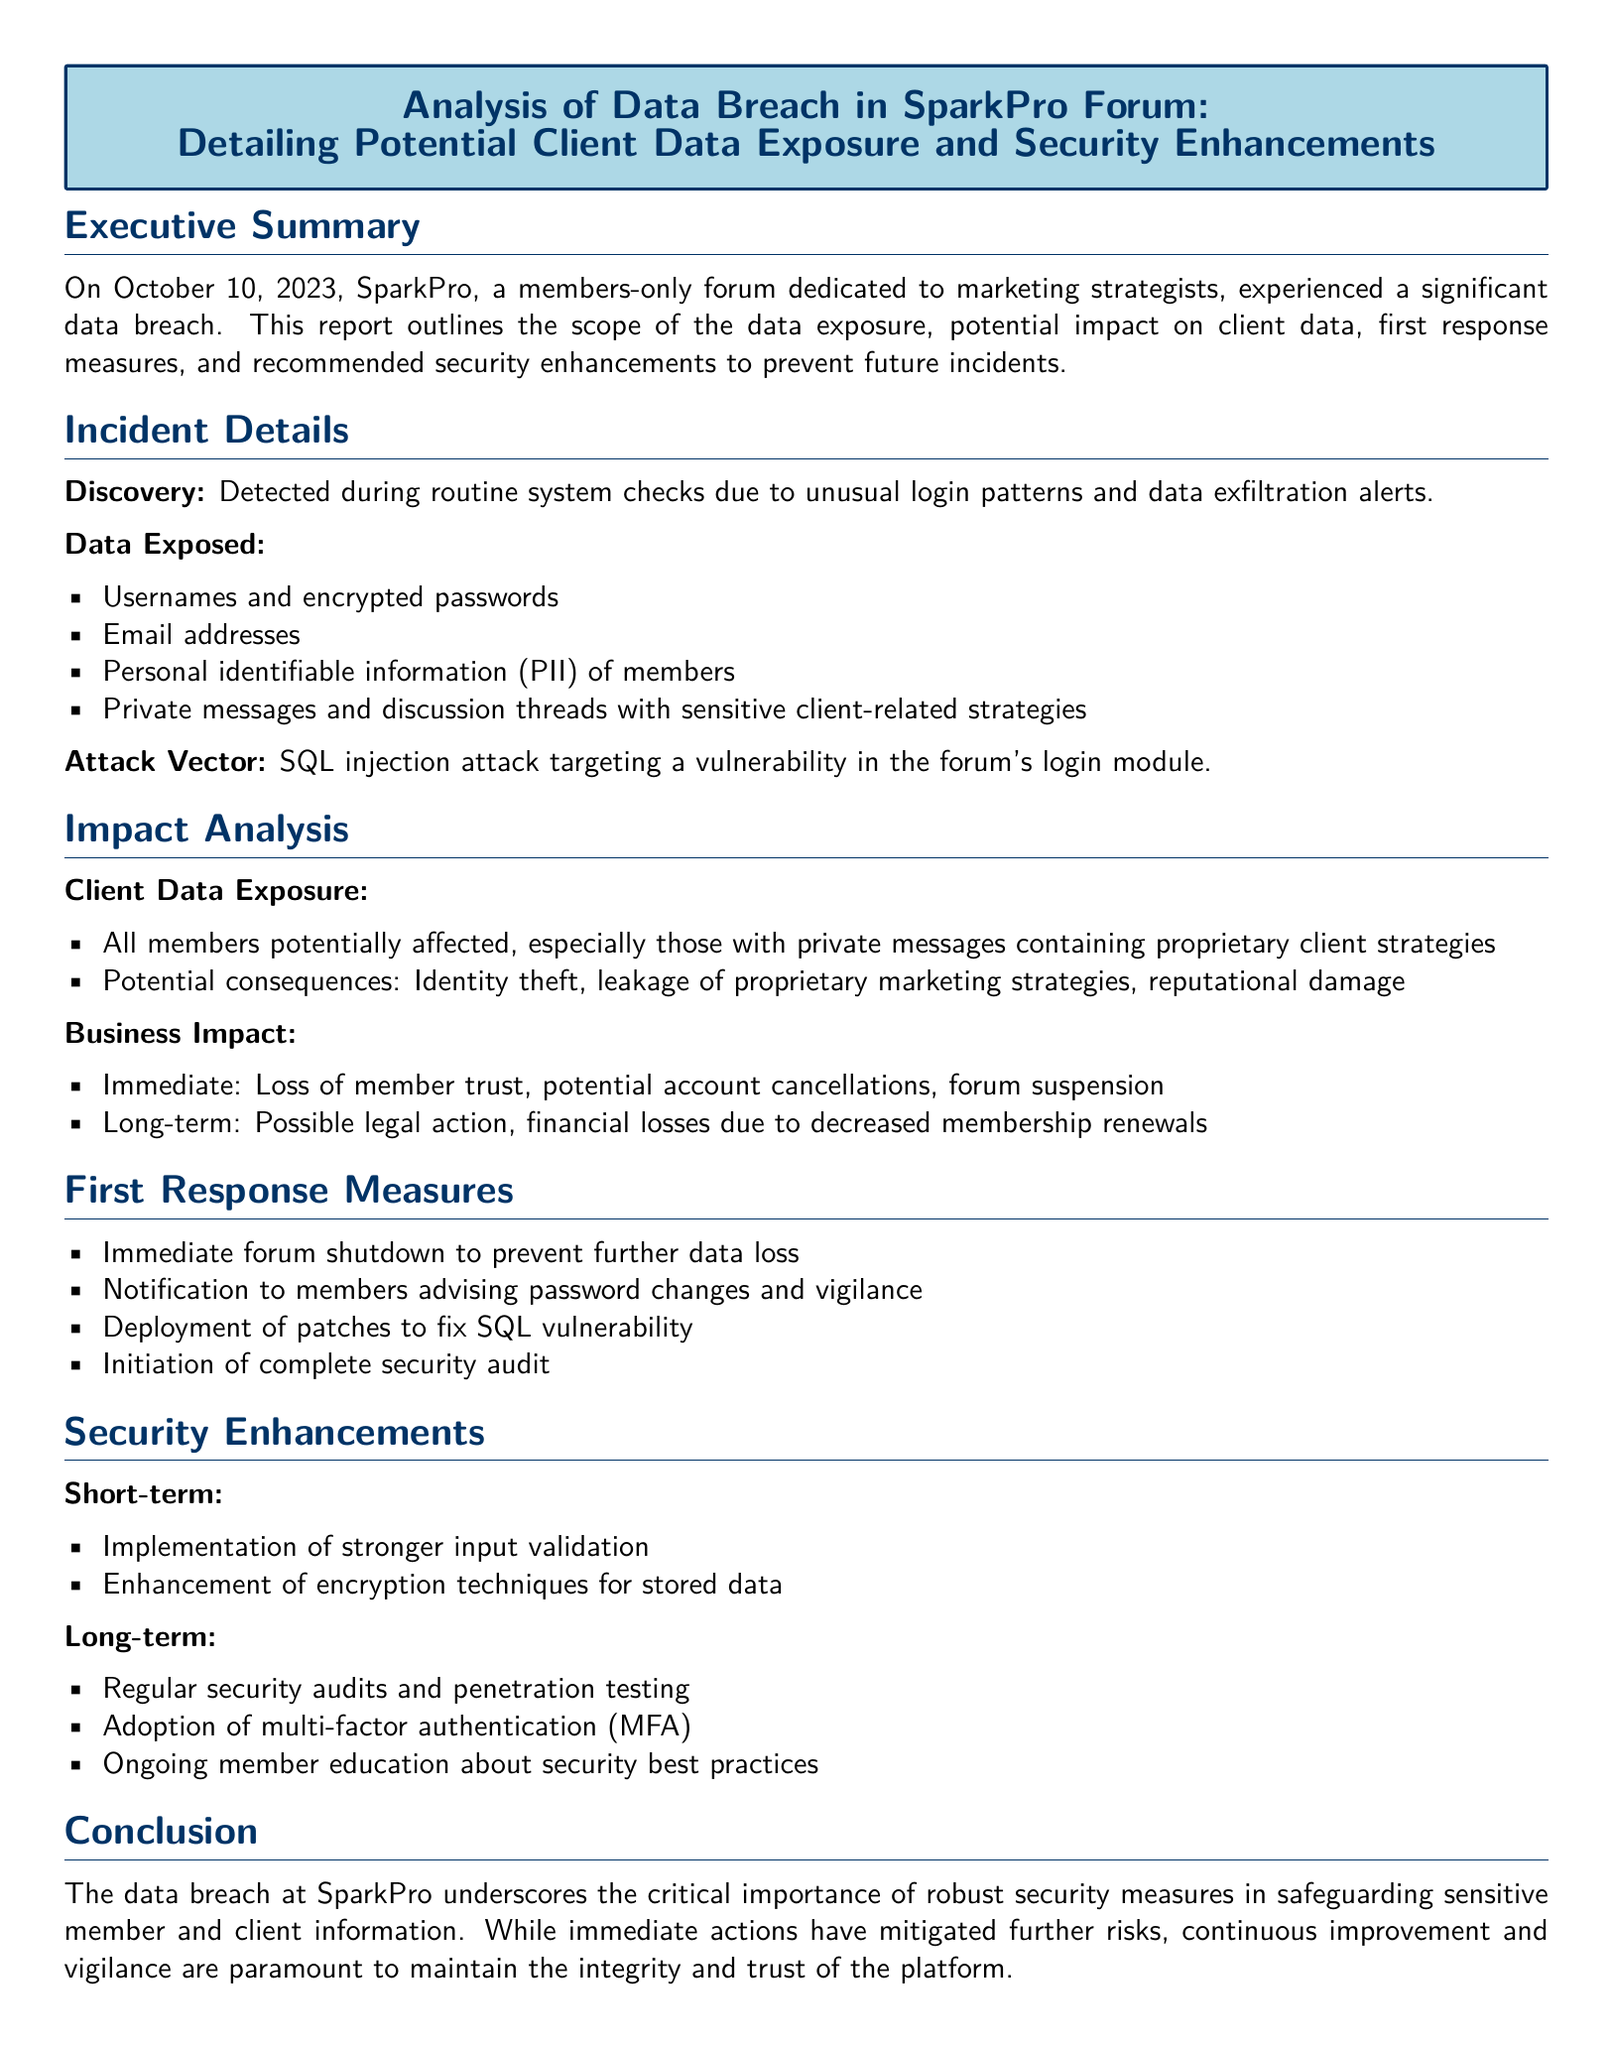what date did the data breach occur? The report states the breach occurred on October 10, 2023.
Answer: October 10, 2023 what was the attack vector used? The document specifies that the SQL injection attack targeted a vulnerability in the forum's login module.
Answer: SQL injection which type of personal information was exposed? The document lists several types of exposed information, including usernames and encrypted passwords.
Answer: Usernames and encrypted passwords what is one potential consequence of the data exposure mentioned? The document outlines several consequences, including identity theft.
Answer: Identity theft what was the immediate first response measure taken? The report mentions that an immediate forum shutdown was executed to prevent further data loss.
Answer: Forum shutdown how many types of security enhancements are listed? The document specifies two categories of security enhancements: short-term and long-term, each with multiple items.
Answer: Two categories what long-term security enhancement was recommended? Among the recommendations, the adoption of multi-factor authentication is mentioned as a long-term security enhancement.
Answer: Multi-factor authentication what could be a potential long-term business impact due to the breach? The report suggests that possible legal action could arise as a long-term business impact.
Answer: Possible legal action 